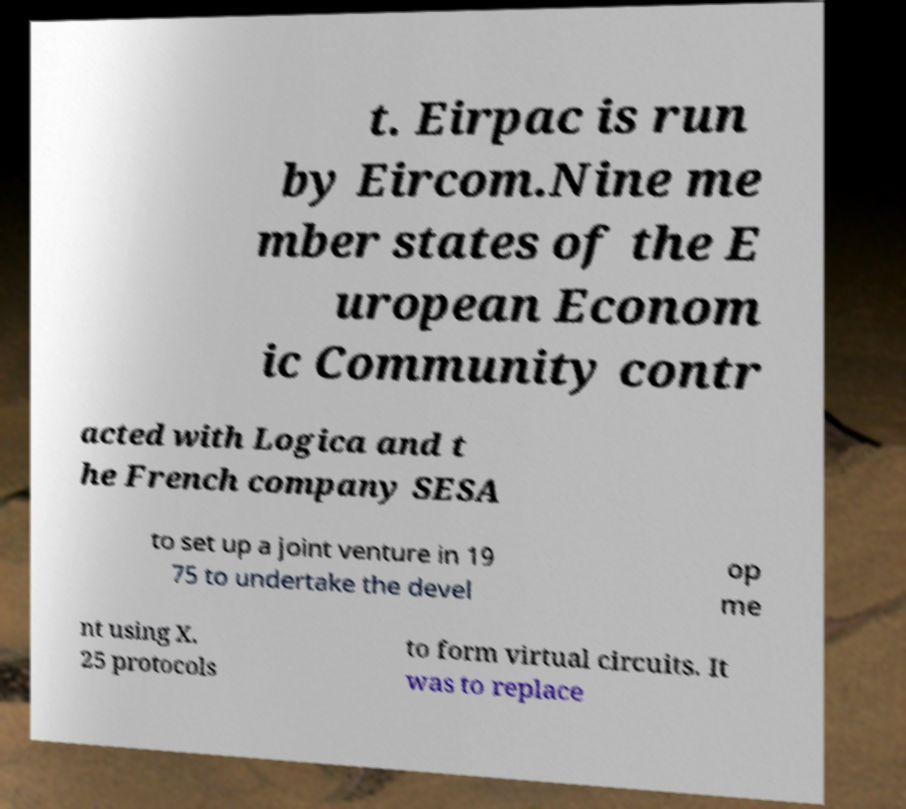I need the written content from this picture converted into text. Can you do that? t. Eirpac is run by Eircom.Nine me mber states of the E uropean Econom ic Community contr acted with Logica and t he French company SESA to set up a joint venture in 19 75 to undertake the devel op me nt using X. 25 protocols to form virtual circuits. It was to replace 